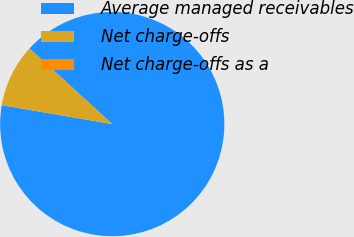<chart> <loc_0><loc_0><loc_500><loc_500><pie_chart><fcel>Average managed receivables<fcel>Net charge-offs<fcel>Net charge-offs as a<nl><fcel>90.91%<fcel>9.09%<fcel>0.0%<nl></chart> 